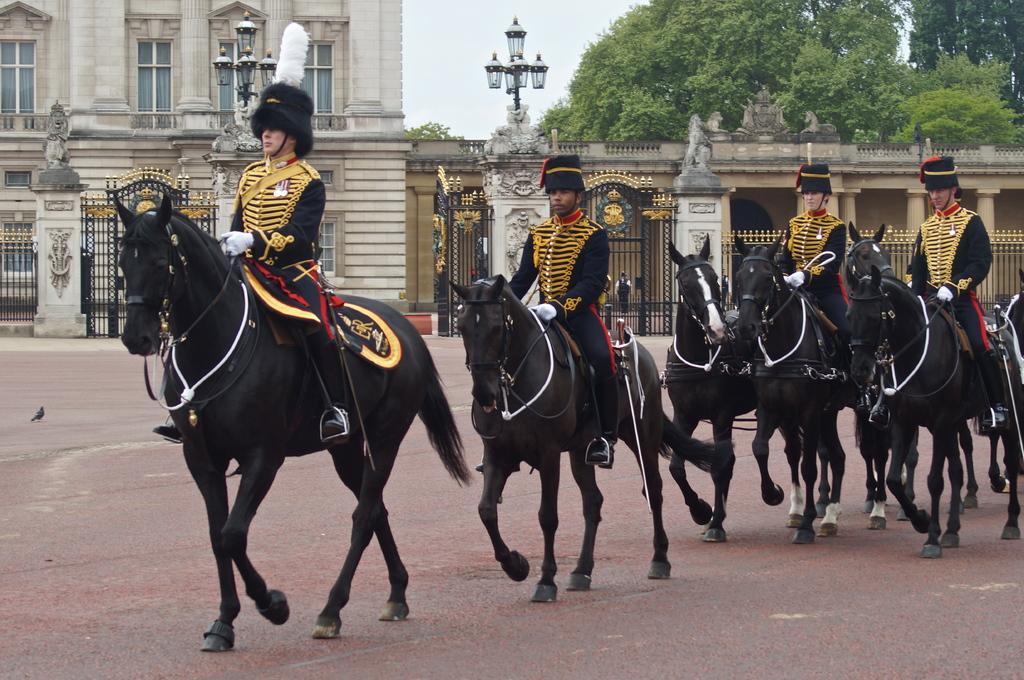In one or two sentences, can you explain what this image depicts? In the picture we can see some people are riding horses they are in a different costumes and the horses are black in color and behind them, we can see a palace and near it, we can see a wall with some gates to it and behind it we can see some trees and sky. 